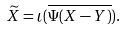Convert formula to latex. <formula><loc_0><loc_0><loc_500><loc_500>\widetilde { X } = \iota ( \overline { \Psi ( X - Y ) } ) .</formula> 